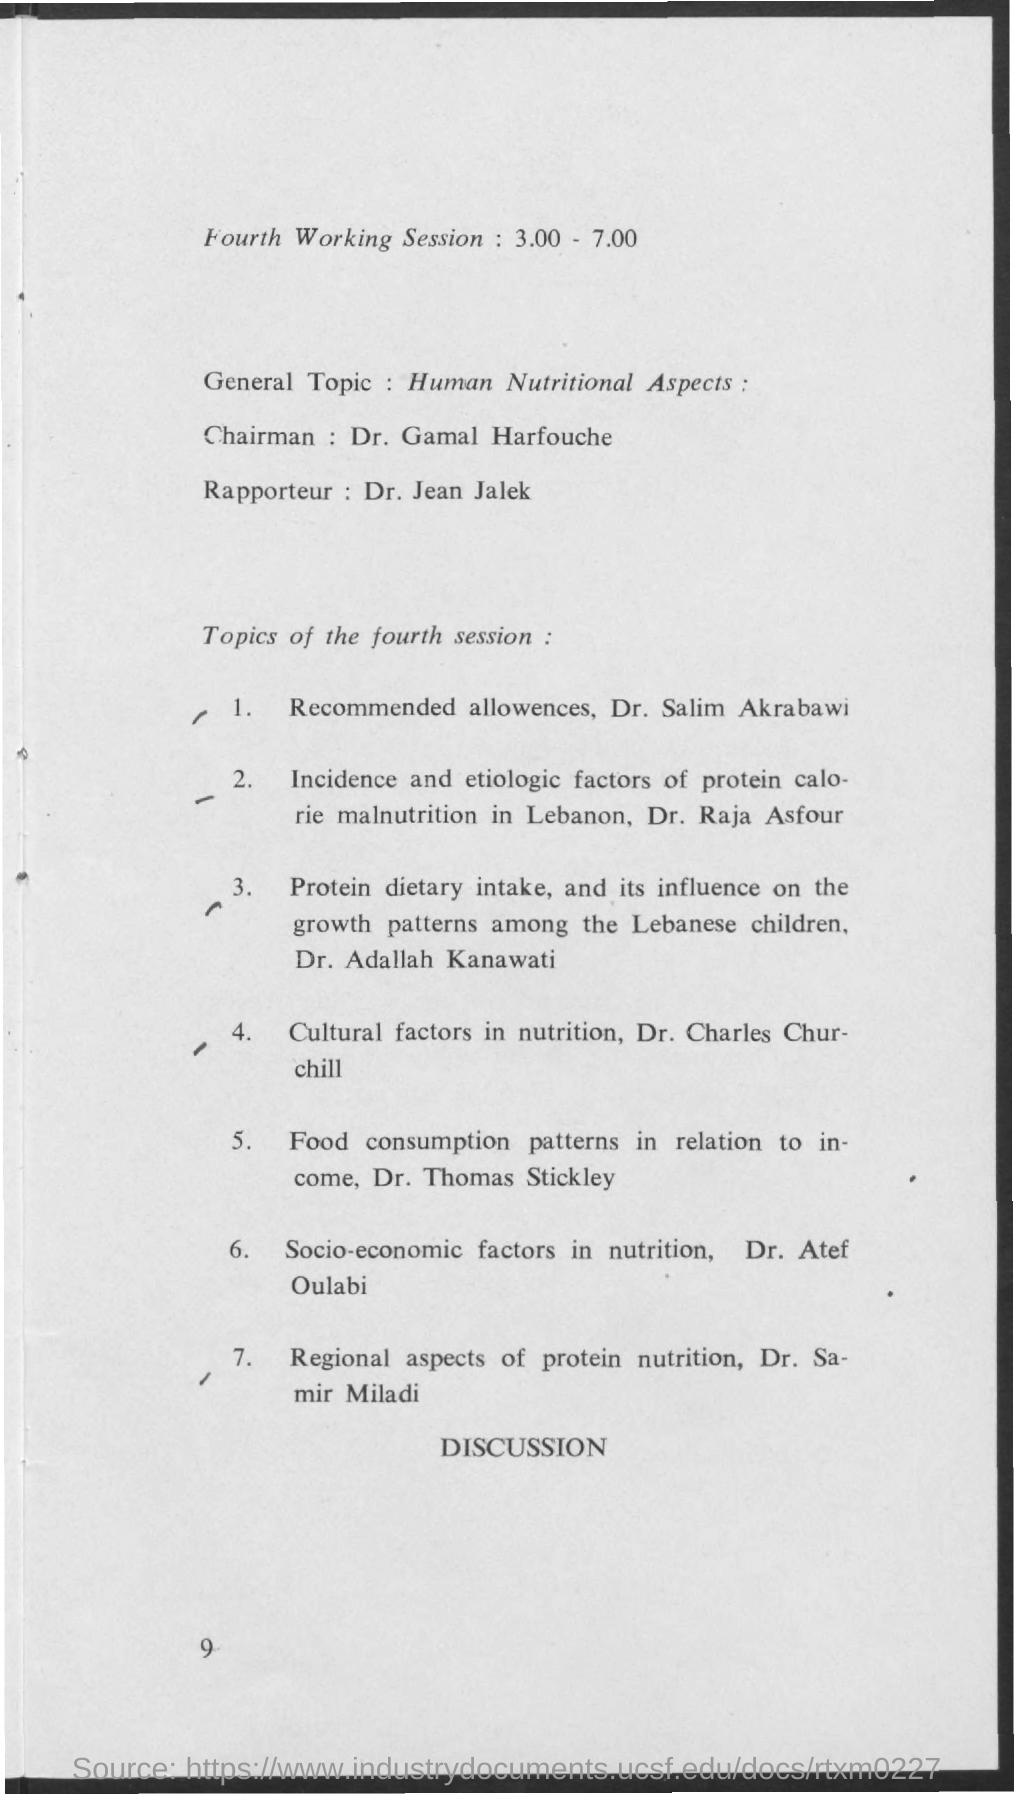List a handful of essential elements in this visual. The general topic mentioned is human nutritional aspects. The fourth working session is expected to take place from 3:00 PM to 7:00 PM. The chairman's name is Dr. Gamal Harfouche. 